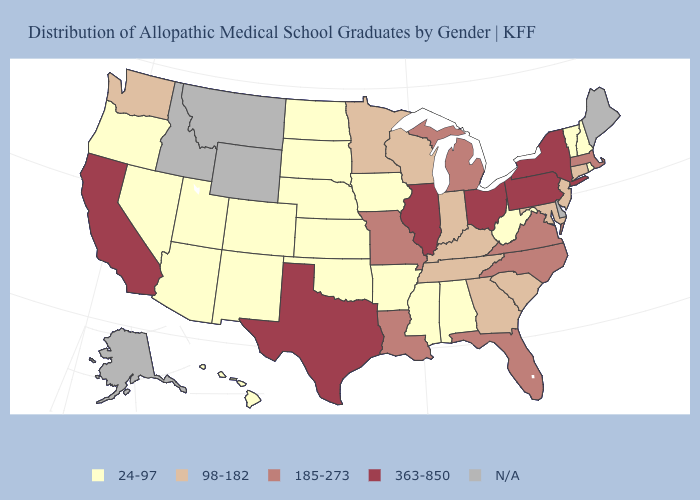Among the states that border Pennsylvania , which have the lowest value?
Keep it brief. West Virginia. What is the value of Idaho?
Concise answer only. N/A. What is the highest value in the USA?
Keep it brief. 363-850. What is the value of Kentucky?
Be succinct. 98-182. What is the value of Oklahoma?
Keep it brief. 24-97. What is the lowest value in the USA?
Quick response, please. 24-97. Which states have the lowest value in the MidWest?
Keep it brief. Iowa, Kansas, Nebraska, North Dakota, South Dakota. How many symbols are there in the legend?
Concise answer only. 5. Name the states that have a value in the range 98-182?
Concise answer only. Connecticut, Georgia, Indiana, Kentucky, Maryland, Minnesota, New Jersey, South Carolina, Tennessee, Washington, Wisconsin. Does New York have the lowest value in the Northeast?
Give a very brief answer. No. 